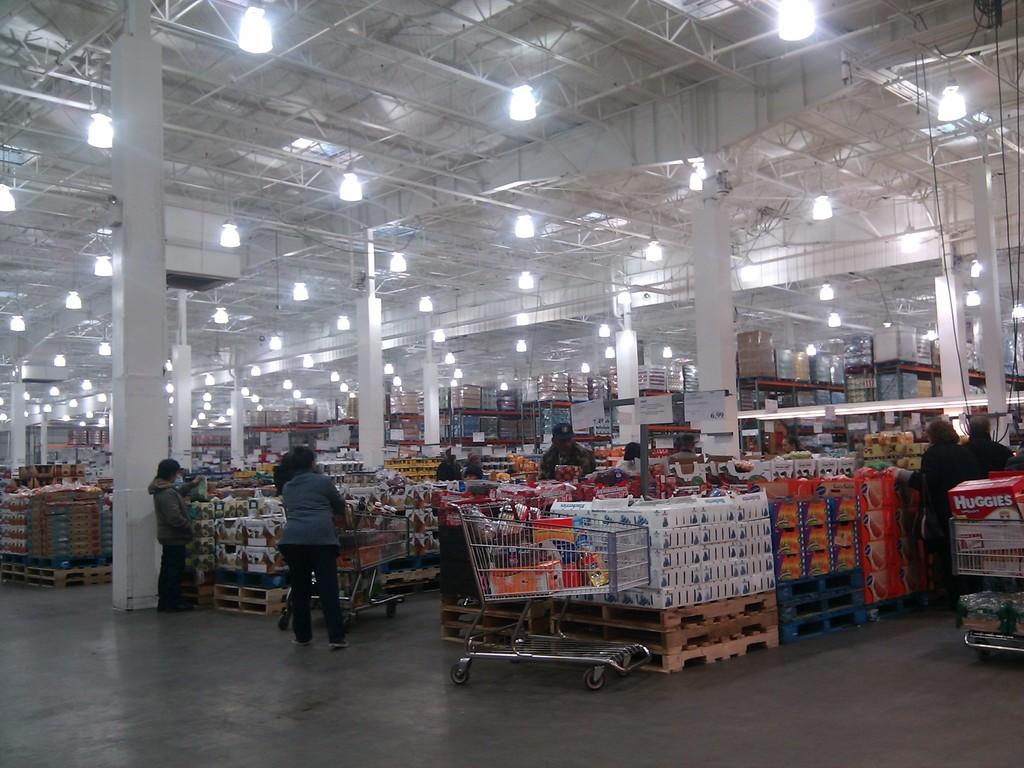<image>
Relay a brief, clear account of the picture shown. A person in a large wholesale supermarket has a box of Huggies in their trolley. 